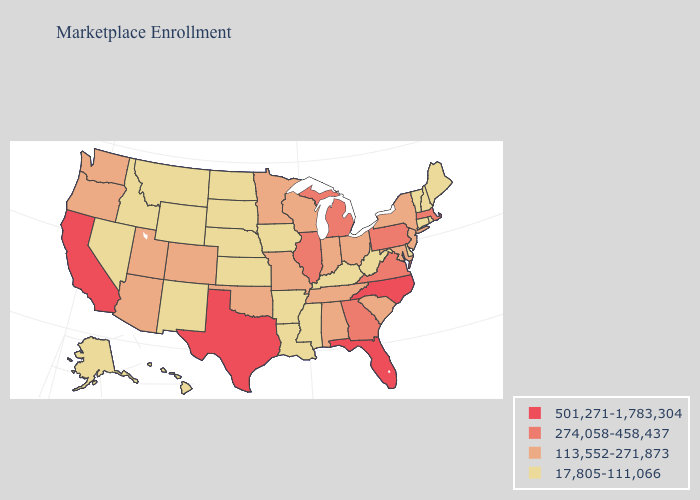Does Mississippi have the lowest value in the USA?
Give a very brief answer. Yes. Name the states that have a value in the range 501,271-1,783,304?
Be succinct. California, Florida, North Carolina, Texas. What is the value of Nebraska?
Answer briefly. 17,805-111,066. Does Pennsylvania have a higher value than California?
Concise answer only. No. What is the value of Oregon?
Quick response, please. 113,552-271,873. Which states have the highest value in the USA?
Concise answer only. California, Florida, North Carolina, Texas. What is the lowest value in the USA?
Be succinct. 17,805-111,066. What is the value of Colorado?
Keep it brief. 113,552-271,873. Does Michigan have a higher value than Minnesota?
Short answer required. Yes. What is the highest value in states that border South Dakota?
Short answer required. 113,552-271,873. What is the value of Oklahoma?
Quick response, please. 113,552-271,873. Name the states that have a value in the range 113,552-271,873?
Write a very short answer. Alabama, Arizona, Colorado, Indiana, Maryland, Minnesota, Missouri, New Jersey, New York, Ohio, Oklahoma, Oregon, South Carolina, Tennessee, Utah, Washington, Wisconsin. Name the states that have a value in the range 501,271-1,783,304?
Be succinct. California, Florida, North Carolina, Texas. Does Tennessee have the lowest value in the USA?
Concise answer only. No. 